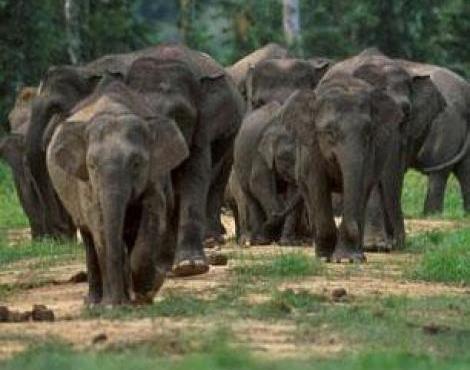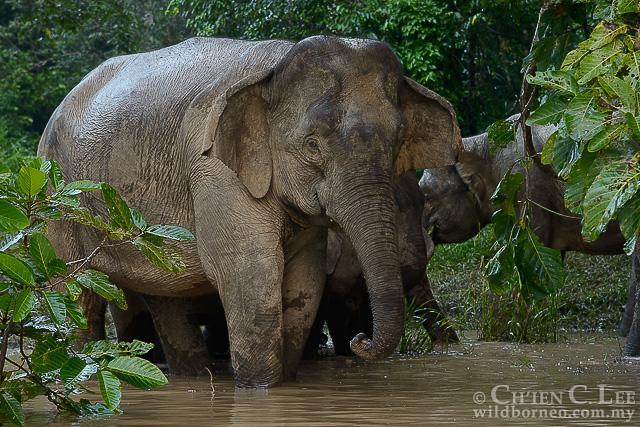The first image is the image on the left, the second image is the image on the right. Analyze the images presented: Is the assertion "At least one image contains one elephant, which has large tusks." valid? Answer yes or no. No. The first image is the image on the left, the second image is the image on the right. Assess this claim about the two images: "There is exactly one animal in the image on the right.". Correct or not? Answer yes or no. No. 